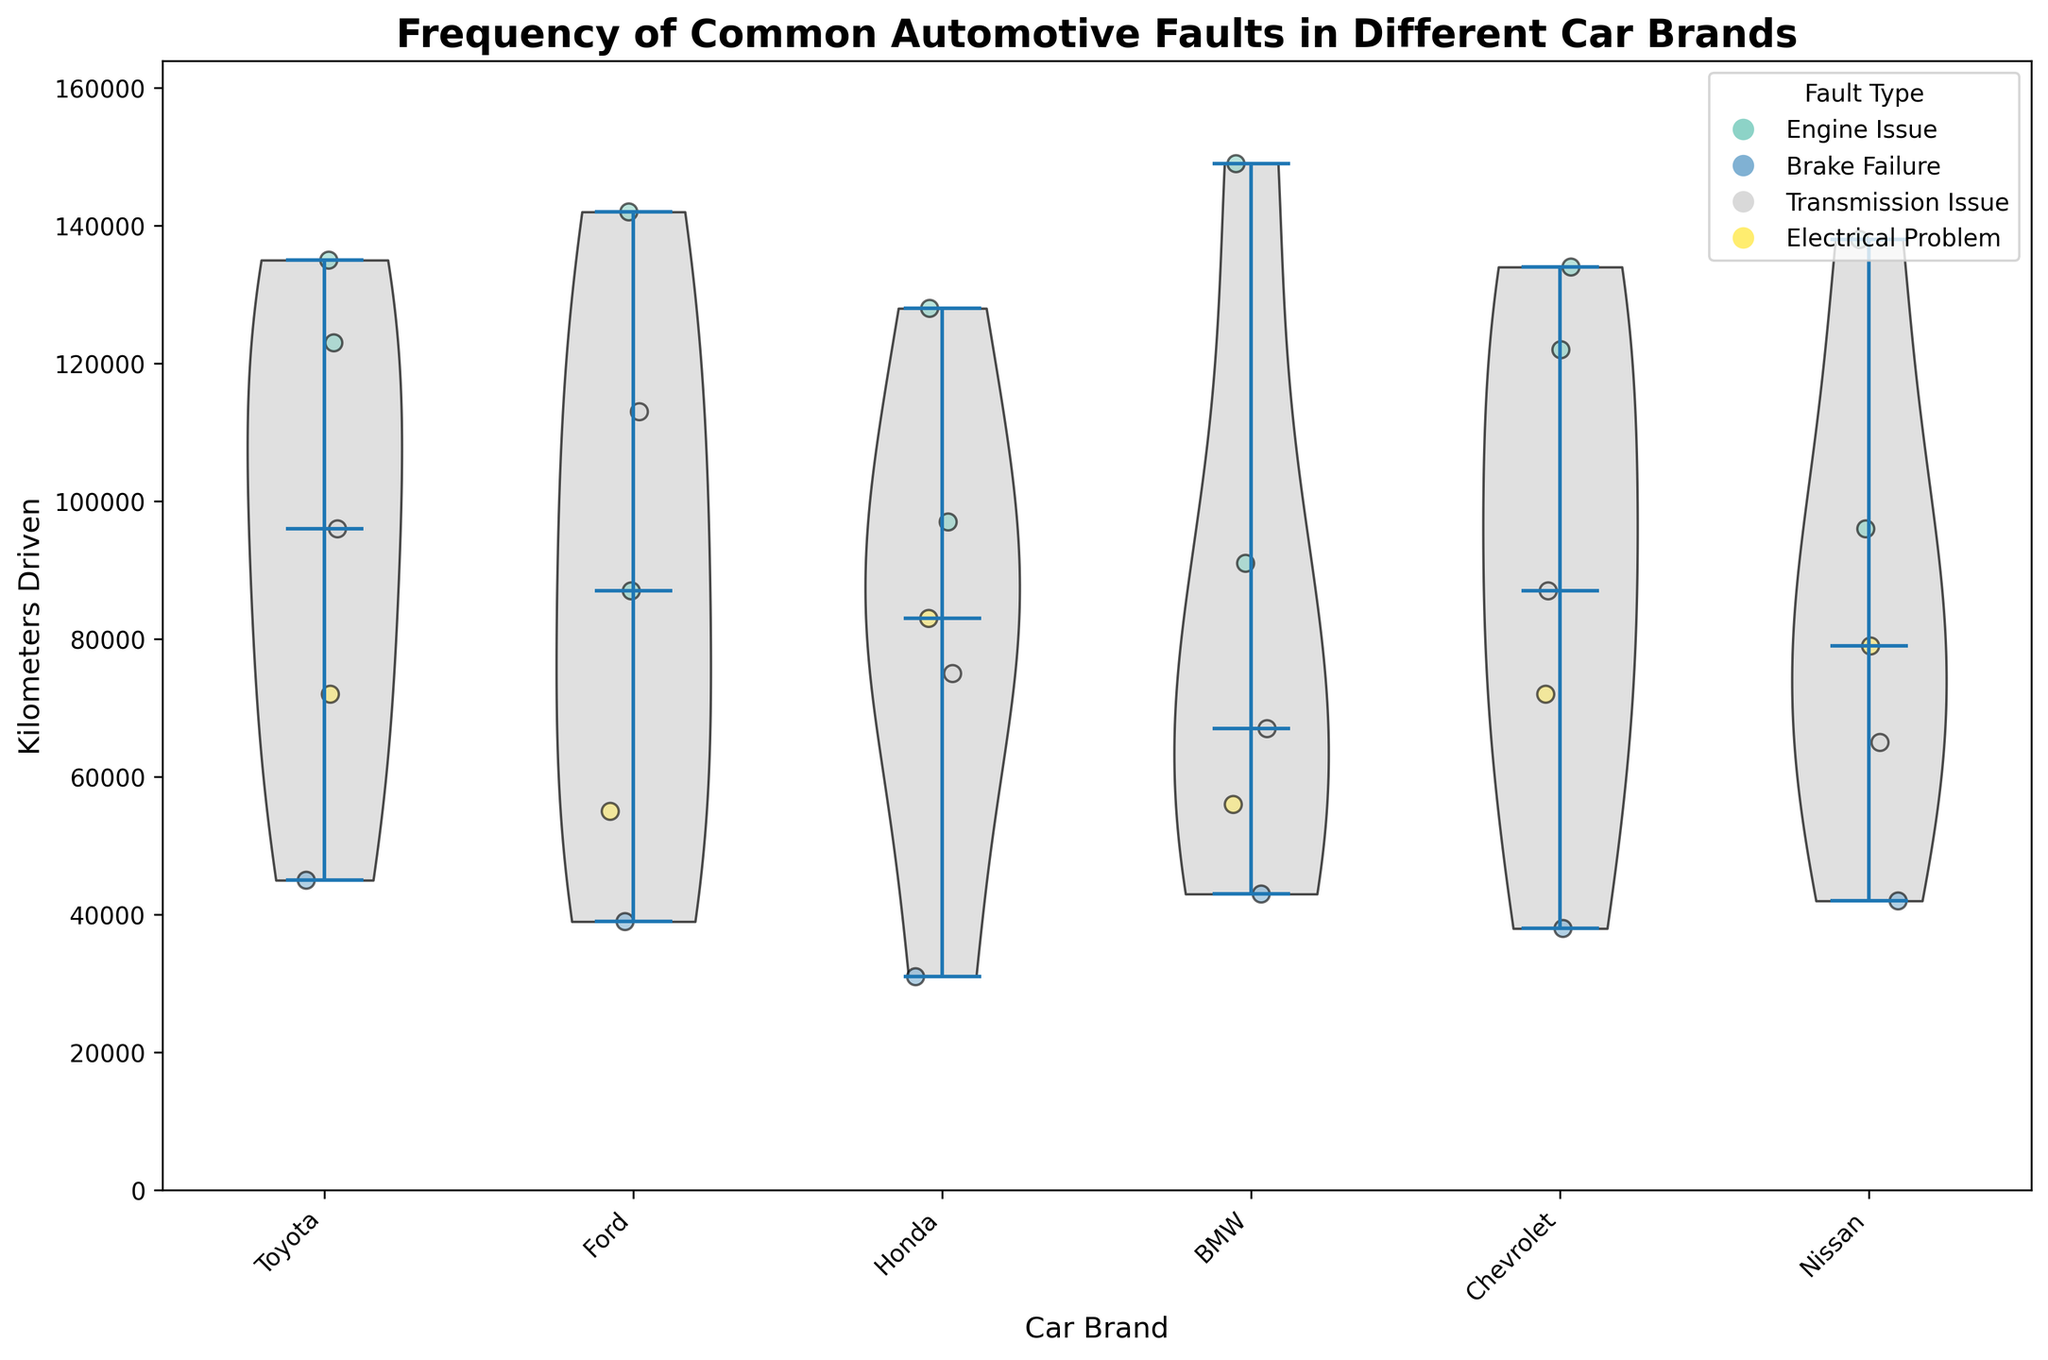How many different car brands are represented in the plot? Look at the x-axis of the chart, which shows the different car brands. Count the number of unique brand names.
Answer: 6 Which fault type has the most reports for Toyota? Observe the scatter points for Toyota and note the color of the most frequent fault type. Refer to the legend to identify the fault type.
Answer: Engine Issue What's the median kilometers driven for Ford vehicles? Identify the violin plot segment associated with Ford. The median is the white dot inside the violin plot segment. Find its y-axis position.
Answer: Approximately 113,000 Which car brand shows the greatest variability in kilometers driven? Examine the width and spread of the violin plot for each brand. The brand with the widest and most spread out violin plot has the greatest variability.
Answer: Chevrolet Are Brake Failures more common in Ford or in Honda? Compare the number of blue-colored scatter points (Brake Failures) for both Ford and Honda. Count the scatter points and compare the quantities.
Answer: Ford What is the range of kilometers driven for Nissan cars? Determine the top and bottom boundaries of the violin plot for Nissan by looking at the vertical spread. Subtract the minimum value from the maximum value on the y-axis.
Answer: Approximately 138,000 - 42,000 = 96,000 Do BMW vehicles have a higher median kilometers driven compared to Honda vehicles? Locate the median values (white dots) in the violin plots for both BMW and Honda. Compare their positions along the y-axis.
Answer: Yes Which car brand experienced the highest kilometers driven for an Electrical Problem fault? Identify the highest scattered point in the color corresponding to Electrical Problem for each car brand, and check the brand with the maximum y-axis value.
Answer: BMW What proportion of Toyota fault reports are related to Engine Issues? Count the number of scattered points for Toyota, then count the number of points corresponding to Engine Issues. Divide the number of Engine Issue points by the total points for Toyota.
Answer: 2/5 = 0.4 or 40% 